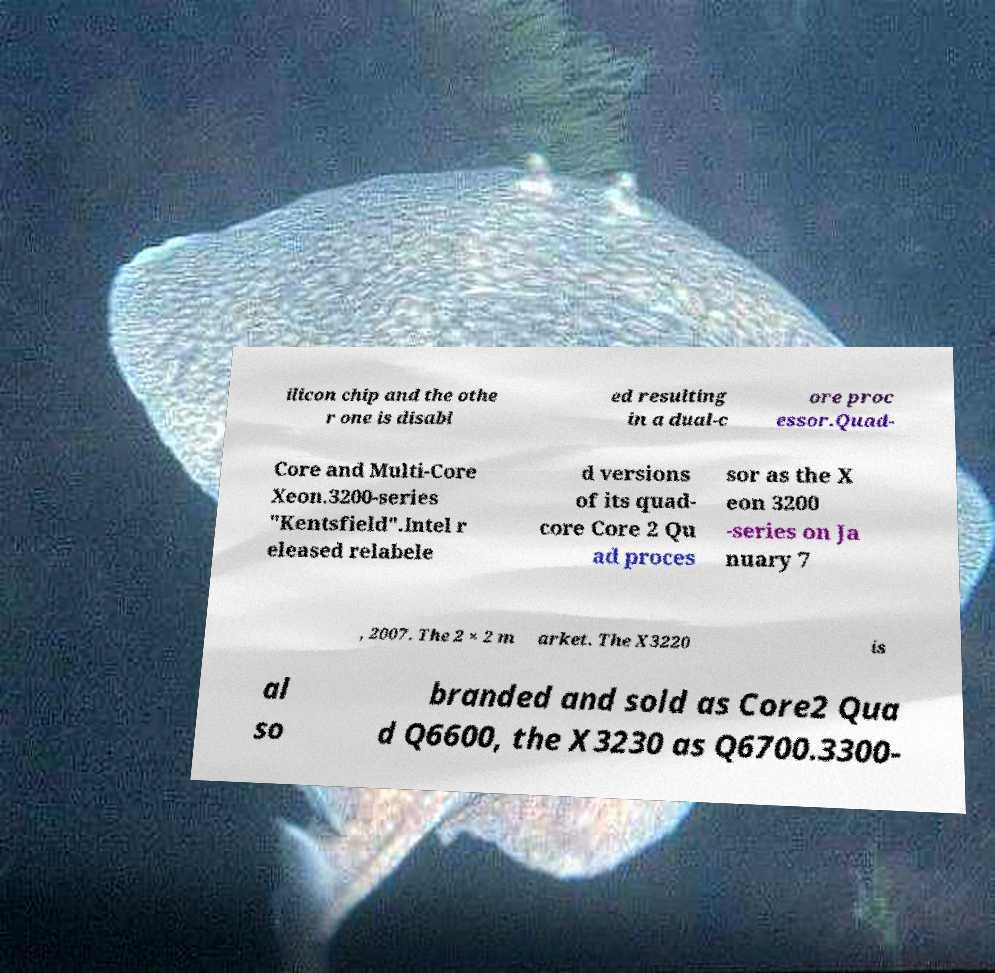I need the written content from this picture converted into text. Can you do that? ilicon chip and the othe r one is disabl ed resulting in a dual-c ore proc essor.Quad- Core and Multi-Core Xeon.3200-series "Kentsfield".Intel r eleased relabele d versions of its quad- core Core 2 Qu ad proces sor as the X eon 3200 -series on Ja nuary 7 , 2007. The 2 × 2 m arket. The X3220 is al so branded and sold as Core2 Qua d Q6600, the X3230 as Q6700.3300- 